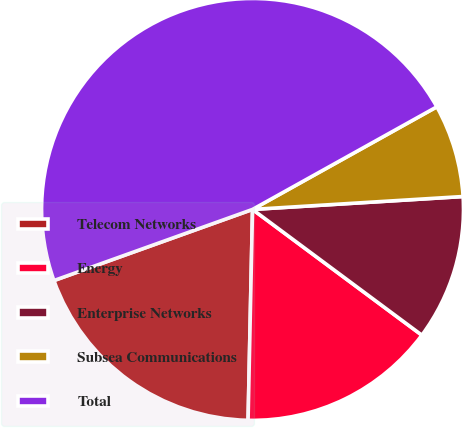<chart> <loc_0><loc_0><loc_500><loc_500><pie_chart><fcel>Telecom Networks<fcel>Energy<fcel>Enterprise Networks<fcel>Subsea Communications<fcel>Total<nl><fcel>19.19%<fcel>15.17%<fcel>11.14%<fcel>7.11%<fcel>47.39%<nl></chart> 